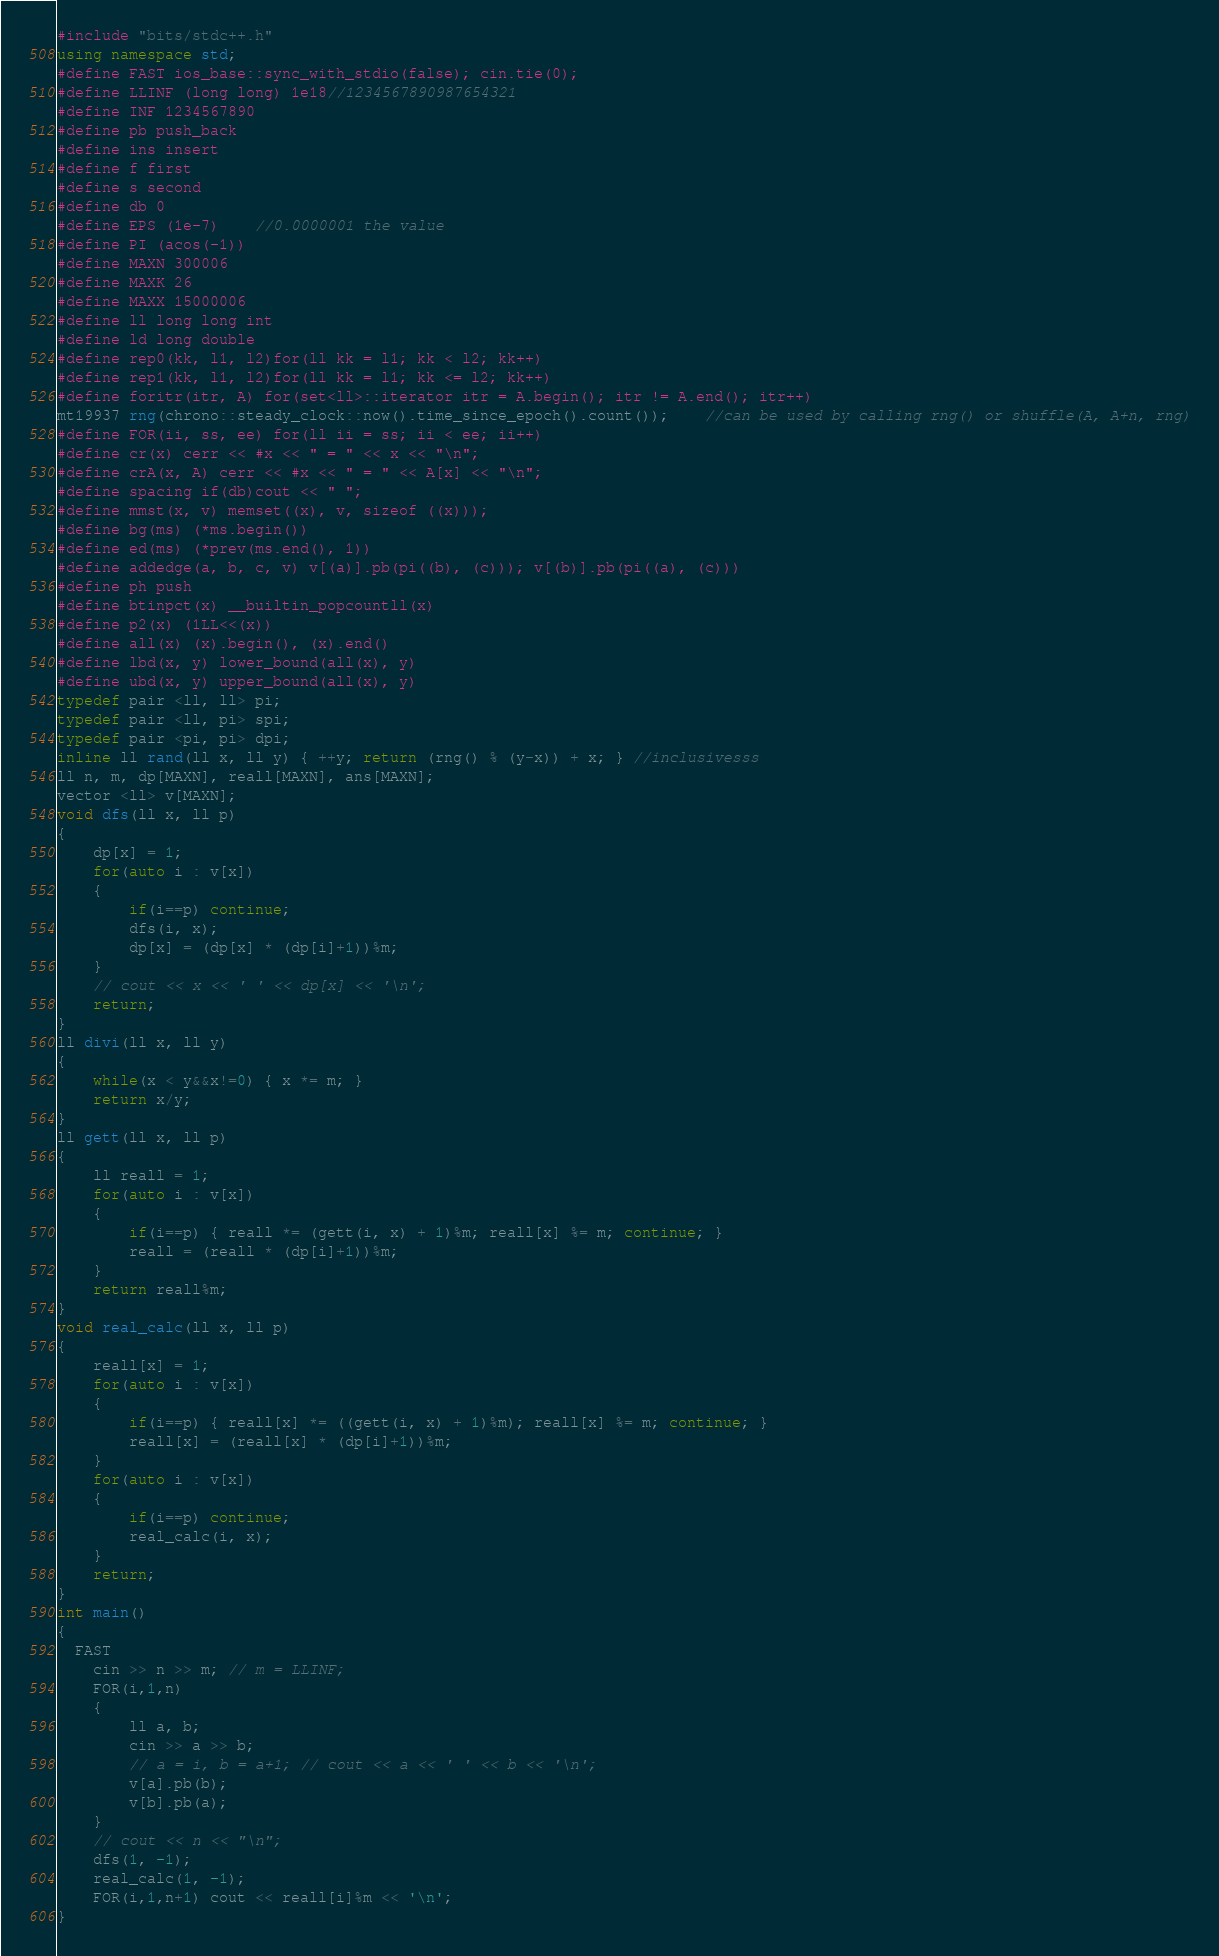Convert code to text. <code><loc_0><loc_0><loc_500><loc_500><_C++_>#include "bits/stdc++.h"
using namespace std;
#define FAST ios_base::sync_with_stdio(false); cin.tie(0);
#define LLINF (long long) 1e18//1234567890987654321
#define INF 1234567890
#define pb push_back
#define ins insert
#define f first
#define s second	
#define db 0
#define EPS (1e-7)    //0.0000001 the value
#define PI (acos(-1))
#define MAXN 300006
#define MAXK 26
#define MAXX 15000006
#define ll long long int
#define ld long double
#define rep0(kk, l1, l2)for(ll kk = l1; kk < l2; kk++)
#define rep1(kk, l1, l2)for(ll kk = l1; kk <= l2; kk++)
#define foritr(itr, A) for(set<ll>::iterator itr = A.begin(); itr != A.end(); itr++)
mt19937 rng(chrono::steady_clock::now().time_since_epoch().count());    //can be used by calling rng() or shuffle(A, A+n, rng)
#define FOR(ii, ss, ee) for(ll ii = ss; ii < ee; ii++)
#define cr(x) cerr << #x << " = " << x << "\n";
#define crA(x, A) cerr << #x << " = " << A[x] << "\n";
#define spacing if(db)cout << " ";
#define mmst(x, v) memset((x), v, sizeof ((x)));
#define bg(ms) (*ms.begin())
#define ed(ms) (*prev(ms.end(), 1))
#define addedge(a, b, c, v) v[(a)].pb(pi((b), (c))); v[(b)].pb(pi((a), (c)))
#define ph push
#define btinpct(x) __builtin_popcountll(x)
#define p2(x) (1LL<<(x))
#define all(x) (x).begin(), (x).end()
#define lbd(x, y) lower_bound(all(x), y)
#define ubd(x, y) upper_bound(all(x), y)
typedef pair <ll, ll> pi;
typedef pair <ll, pi> spi;
typedef pair <pi, pi> dpi;
inline ll rand(ll x, ll y) { ++y; return (rng() % (y-x)) + x; } //inclusivesss
ll n, m, dp[MAXN], reall[MAXN], ans[MAXN];
vector <ll> v[MAXN];
void dfs(ll x, ll p)
{
	dp[x] = 1;
	for(auto i : v[x])
	{
		if(i==p) continue;
		dfs(i, x);
		dp[x] = (dp[x] * (dp[i]+1))%m;
	}
	// cout << x << ' ' << dp[x] << '\n';
	return;
}
ll divi(ll x, ll y)
{
	while(x < y&&x!=0) { x *= m; }
	return x/y;
}
ll gett(ll x, ll p)
{
	ll reall = 1;
	for(auto i : v[x])
	{
		if(i==p) { reall *= (gett(i, x) + 1)%m; reall[x] %= m; continue; }
		reall = (reall * (dp[i]+1))%m;
	}
	return reall%m;
}
void real_calc(ll x, ll p)
{
	reall[x] = 1;
	for(auto i : v[x])
	{
		if(i==p) { reall[x] *= ((gett(i, x) + 1)%m); reall[x] %= m; continue; }
		reall[x] = (reall[x] * (dp[i]+1))%m;
	}
	for(auto i : v[x])
	{
		if(i==p) continue;
		real_calc(i, x); 
	}
	return;
}
int main()
{
  FAST
	cin >> n >> m; // m = LLINF;
	FOR(i,1,n)
	{
		ll a, b;
		cin >> a >> b; 
		// a = i, b = a+1; // cout << a << ' ' << b << '\n';
		v[a].pb(b);
		v[b].pb(a);
	}
	// cout << n << "\n";
	dfs(1, -1);
	real_calc(1, -1);
	FOR(i,1,n+1) cout << reall[i]%m << '\n';
}
</code> 